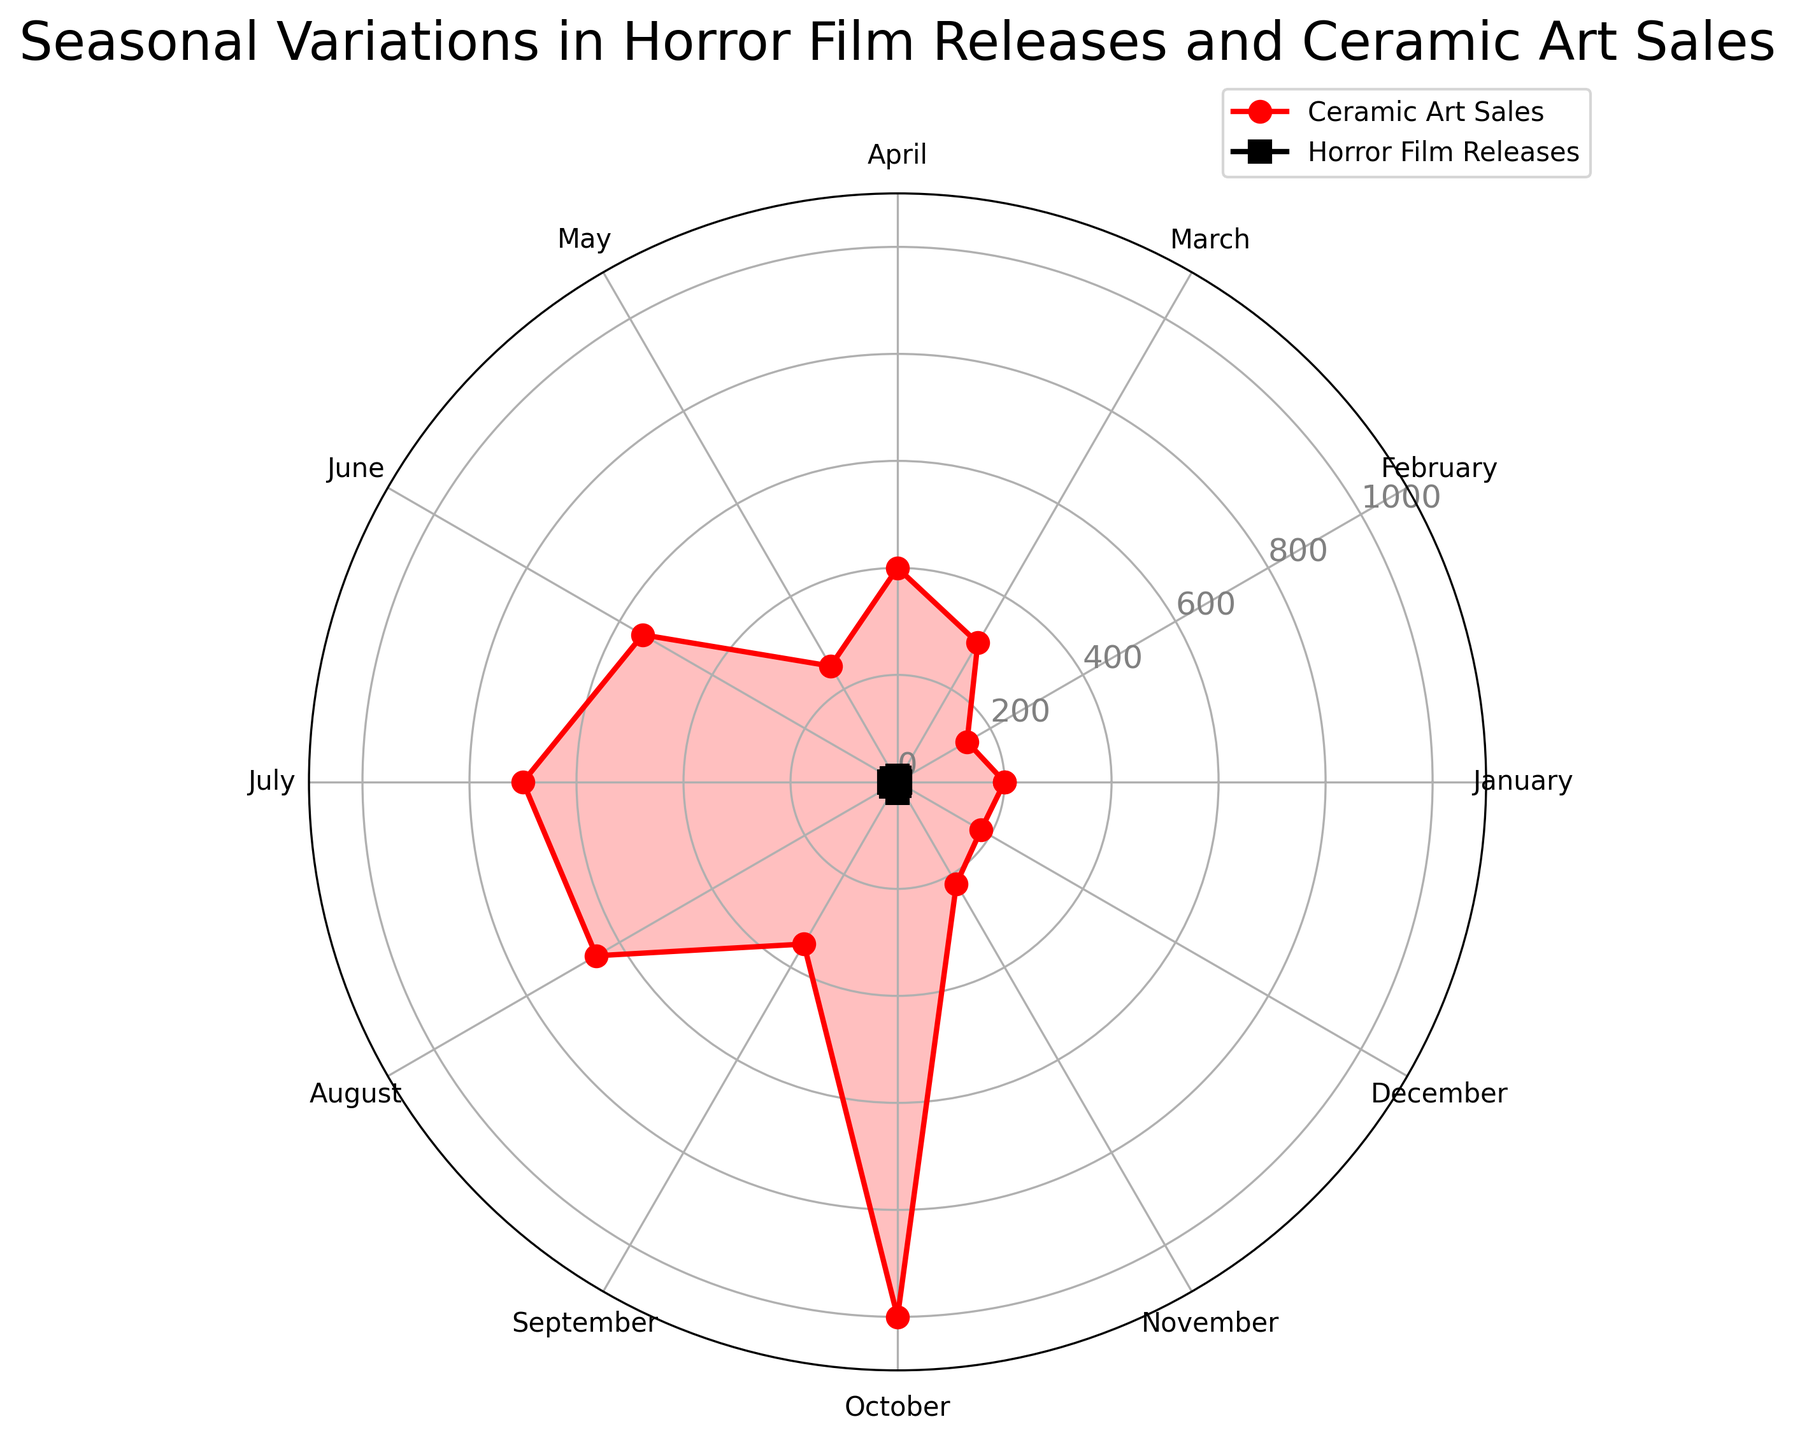What is the common ceramic theme in October? The figure shows a legend or labels indicating the common ceramic themes for each month. By referring to October, we identify the related theme.
Answer: Classic Horror Which month has the highest sales of ceramic art, and what is the common theme during that month? Identify the peak point on the ceramic art sales plot and refer to the corresponding month. Then check the common theme for that month.
Answer: October, Classic Horror Compare July and January in terms of horror film releases and ceramic art sales. Which month has higher values in both categories? Locate July and January on both the horror film releases and ceramic art sales plots, then compare the values. Both horror film releases and ceramic art sales are higher in July.
Answer: July How many horror films are released from January to March inclusive? Add the values of horror film releases for January, February, and March.
Answer: 16 What is the average ceramic art sales from April to June? Add the ceramic art sales for April, May, and June, then divide by 3 to find the average.
Answer: 400 Which month shows both the highest horror film releases and the highest ceramic art sales? Identify the months with peaks in both the horror film releases plot and ceramic art sales plot, checking if they're the same.
Answer: October Is there a month where horror film releases exceed ceramic art sales? Compare values between the horror film releases plot and ceramic art sales plot for each month to determine if there's any month where the releases plot is higher.
Answer: No Identify the trend in horror film releases from June to October. Observe the horror film releases plot from June to October, noting whether it increases, decreases, or remains constant.
Answer: Increasing How do the ceramic art themes vary between January and December? Refer to the common ceramic themes labeled for January and December and compare them.
Answer: Gothic to Winter Fantasy 